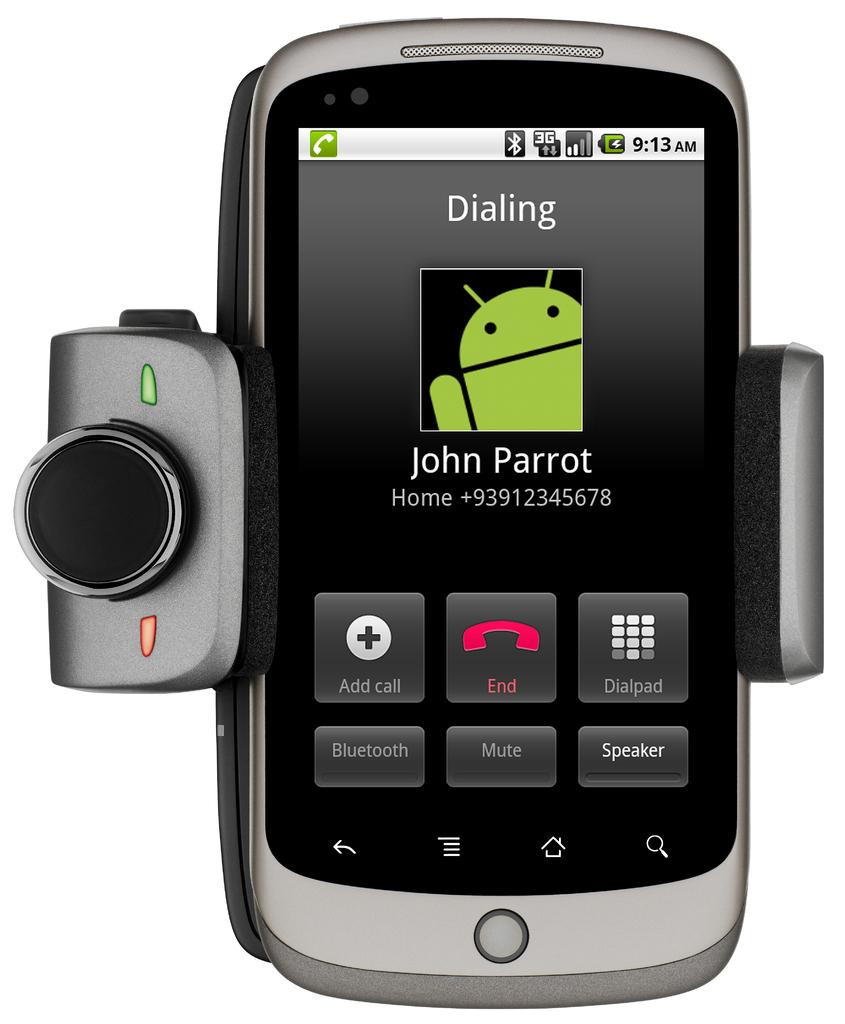<image>
Provide a brief description of the given image. a cell phone with an attached camera is Dialing John Parrot 